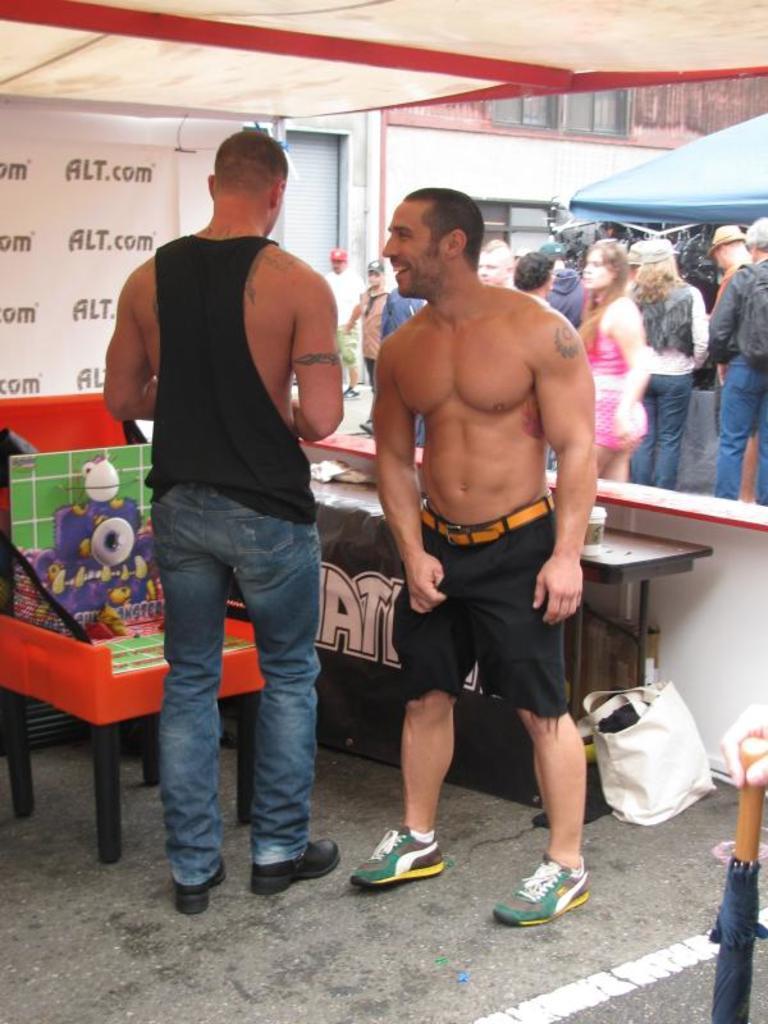Please provide a concise description of this image. In this image there are two men standing, there are tables, there are objects on the tables, there is a board towards the right of the image, there is text on the board, there is a wall, there are windows, there is road towards the bottom of the image, there are objects on the road, there is an object towards the right of the image, there is a person's hand towards the right of the image, there are groups of persons standing, there is a tent towards the right of the image, there is a tent roof towards the top of the image. 